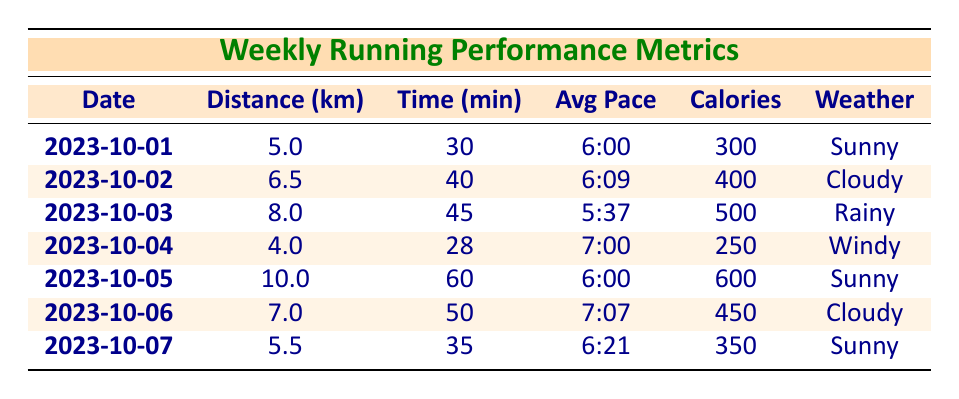What is the longest distance run in a week? The maximum distance in the table is 10.0 km, which occurred on 2023-10-05.
Answer: 10.0 km What was the total number of calories burned throughout the week? By adding up the calories burned from each entry: 300 + 400 + 500 + 250 + 600 + 450 + 350 = 2850 calories burned in total.
Answer: 2850 calories On which date was the average pace the fastest? The average pace of 5:37 on 2023-10-03 is the fastest when compared to the other days, indicating the quickest running speed.
Answer: 2023-10-03 Was there a day when the running was performed in windy weather? Yes, on 2023-10-04, the weather condition was recorded as windy.
Answer: Yes What was the average distance run across the week? The distances are: 5.0, 6.5, 8.0, 4.0, 10.0, 7.0, and 5.5 km, yielding a total of 46.0 km. Dividing by 7 days gives an average of 46.0 / 7 = 6.57 km per day.
Answer: 6.57 km What was the total time spent running for the week? Adding the time for each day gives: 30 + 40 + 45 + 28 + 60 + 50 + 35 = 288 minutes spent running in total for the week.
Answer: 288 minutes On which days was the running performed in sunny weather? The sunny days listed in the data are 2023-10-01, 2023-10-05, and 2023-10-07, indicating three days of running in sunny conditions.
Answer: 2023-10-01, 2023-10-05, 2023-10-07 What was the average pace on the day with the highest calorie burn? On 2023-10-05, there was a calorie burn of 600. The average pace on this day was recorded as 6:00, therefore this is the desired average pace for the highest calorie burn.
Answer: 6:00 Was there a day when the distance was less than 5 km? Yes, on 2023-10-04, the distance run was only 4.0 km, indicating that running occurred below the 5 km mark.
Answer: Yes 